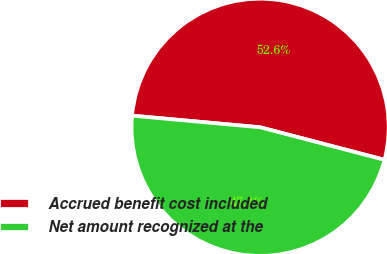Convert chart to OTSL. <chart><loc_0><loc_0><loc_500><loc_500><pie_chart><fcel>Accrued benefit cost included<fcel>Net amount recognized at the<nl><fcel>52.63%<fcel>47.37%<nl></chart> 